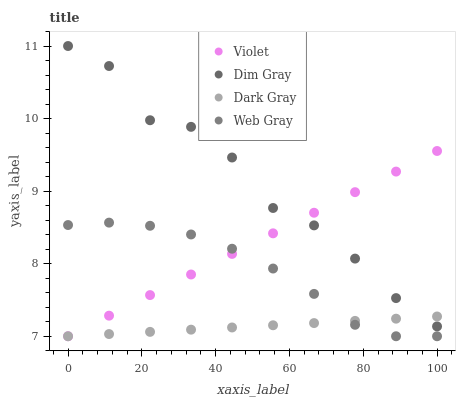Does Dark Gray have the minimum area under the curve?
Answer yes or no. Yes. Does Dim Gray have the maximum area under the curve?
Answer yes or no. Yes. Does Web Gray have the minimum area under the curve?
Answer yes or no. No. Does Web Gray have the maximum area under the curve?
Answer yes or no. No. Is Violet the smoothest?
Answer yes or no. Yes. Is Dim Gray the roughest?
Answer yes or no. Yes. Is Web Gray the smoothest?
Answer yes or no. No. Is Web Gray the roughest?
Answer yes or no. No. Does Dark Gray have the lowest value?
Answer yes or no. Yes. Does Dim Gray have the lowest value?
Answer yes or no. No. Does Dim Gray have the highest value?
Answer yes or no. Yes. Does Web Gray have the highest value?
Answer yes or no. No. Is Web Gray less than Dim Gray?
Answer yes or no. Yes. Is Dim Gray greater than Web Gray?
Answer yes or no. Yes. Does Dark Gray intersect Dim Gray?
Answer yes or no. Yes. Is Dark Gray less than Dim Gray?
Answer yes or no. No. Is Dark Gray greater than Dim Gray?
Answer yes or no. No. Does Web Gray intersect Dim Gray?
Answer yes or no. No. 